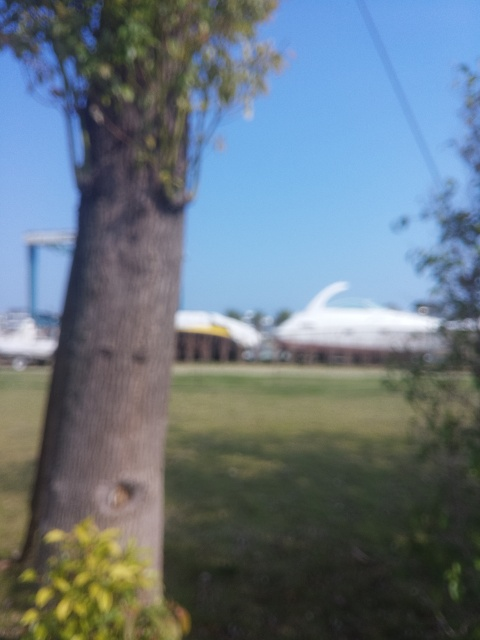What could be the possible reasons for this image being out of focus? There are several reasons why an image might be out of focus. It could be due to an incorrect camera setting, such as an inappropriate aperture or shutter speed for the lighting conditions. It might also be the result of camera movement during the exposure or focusing on the wrong part of the scene. In some cases, it's also possible that the autofocus was not locked on a subject before taking the picture.  Is there any way to correct the focus of this image after it has been taken? Once an image has been captured out of focus, there is a limited scope for correction. Some post-processing software can sharpen an image to an extent, but they cannot recreate the fine details that were originally out of focus. The best practice is to retake the photo with proper focusing techniques. For important moments that cannot be recreated, advanced image processing techniques can assist, but the results are generally not as good as an originally sharp image. 